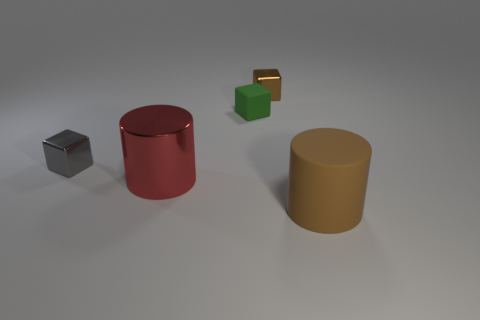There is a object behind the small green object; does it have the same color as the big cylinder that is in front of the large metallic object?
Provide a succinct answer. Yes. Are there any other things that are the same color as the rubber cylinder?
Provide a short and direct response. Yes. The small object that is the same color as the large rubber thing is what shape?
Provide a short and direct response. Cube. There is a metal cube to the right of the red metallic thing; is its color the same as the matte cylinder?
Make the answer very short. Yes. Are the brown cylinder and the green object made of the same material?
Provide a short and direct response. Yes. What number of cylinders are on the right side of the rubber object that is behind the cylinder behind the rubber cylinder?
Your answer should be compact. 1. What is the color of the big cylinder that is left of the big matte cylinder?
Ensure brevity in your answer.  Red. What shape is the tiny metallic object behind the tiny metallic object to the left of the tiny brown object?
Your answer should be compact. Cube. How many balls are either red metal objects or small shiny things?
Offer a terse response. 0. There is a thing that is both in front of the small green cube and behind the red thing; what material is it?
Offer a very short reply. Metal. 